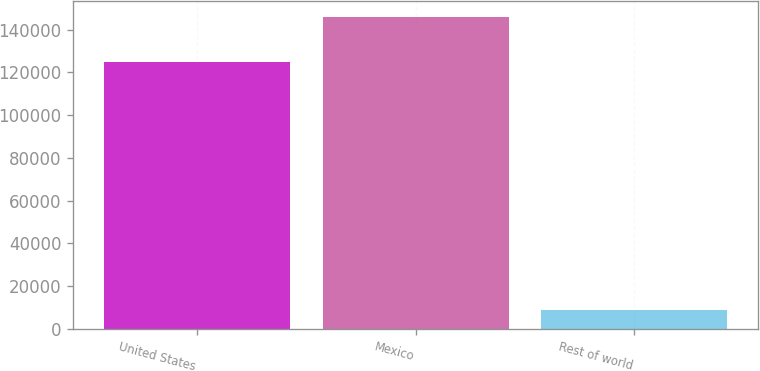<chart> <loc_0><loc_0><loc_500><loc_500><bar_chart><fcel>United States<fcel>Mexico<fcel>Rest of world<nl><fcel>124777<fcel>145935<fcel>8671<nl></chart> 